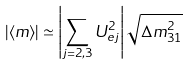Convert formula to latex. <formula><loc_0><loc_0><loc_500><loc_500>| \langle m \rangle | \simeq \left | \sum _ { j = 2 , 3 } U _ { e j } ^ { 2 } \right | \sqrt { \Delta m _ { 3 1 } ^ { 2 } }</formula> 